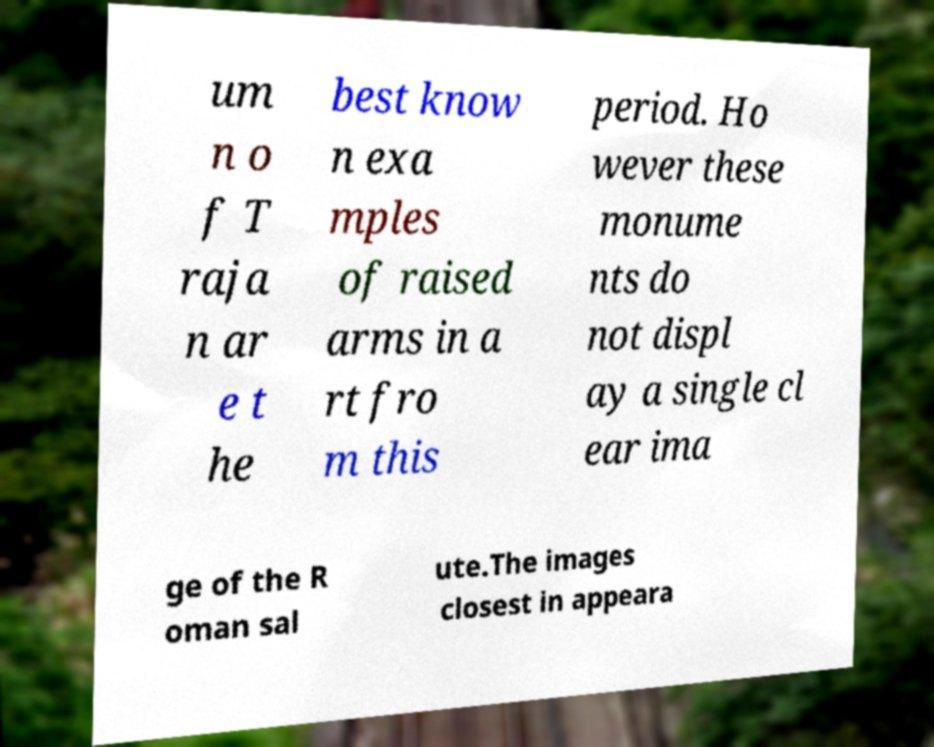Could you assist in decoding the text presented in this image and type it out clearly? um n o f T raja n ar e t he best know n exa mples of raised arms in a rt fro m this period. Ho wever these monume nts do not displ ay a single cl ear ima ge of the R oman sal ute.The images closest in appeara 